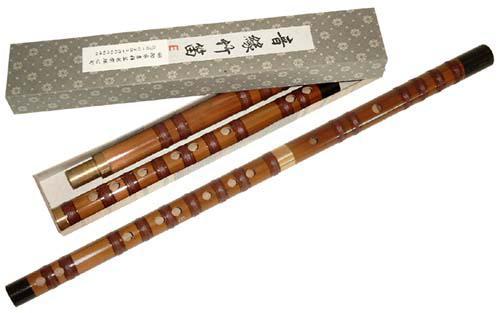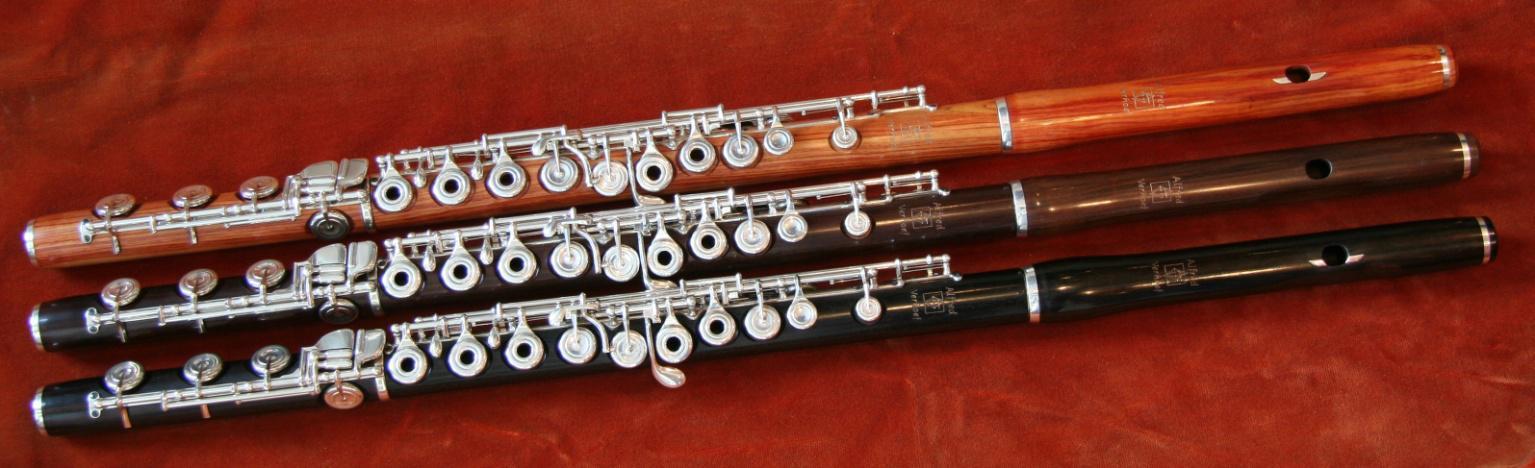The first image is the image on the left, the second image is the image on the right. Analyze the images presented: Is the assertion "There are two flutes and one of them is in two pieces." valid? Answer yes or no. No. The first image is the image on the left, the second image is the image on the right. Evaluate the accuracy of this statement regarding the images: "There is exactly one assembled flute in the left image.". Is it true? Answer yes or no. Yes. 